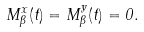Convert formula to latex. <formula><loc_0><loc_0><loc_500><loc_500>M ^ { x } _ { \beta } ( t ) = M ^ { y } _ { \beta } ( t ) = 0 .</formula> 